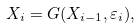Convert formula to latex. <formula><loc_0><loc_0><loc_500><loc_500>X _ { i } = G ( X _ { i - 1 } , \varepsilon _ { i } ) ,</formula> 